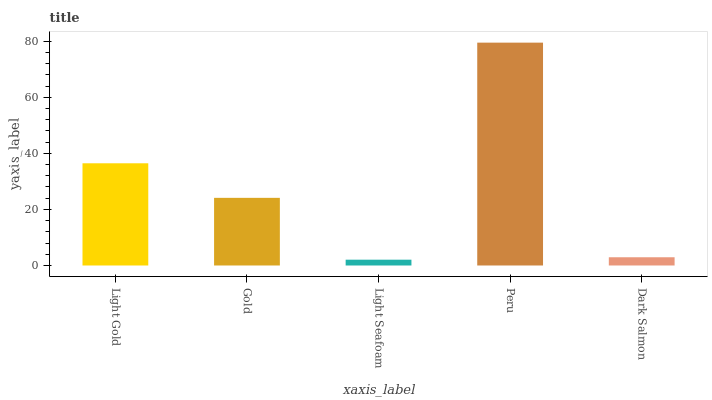Is Gold the minimum?
Answer yes or no. No. Is Gold the maximum?
Answer yes or no. No. Is Light Gold greater than Gold?
Answer yes or no. Yes. Is Gold less than Light Gold?
Answer yes or no. Yes. Is Gold greater than Light Gold?
Answer yes or no. No. Is Light Gold less than Gold?
Answer yes or no. No. Is Gold the high median?
Answer yes or no. Yes. Is Gold the low median?
Answer yes or no. Yes. Is Peru the high median?
Answer yes or no. No. Is Dark Salmon the low median?
Answer yes or no. No. 